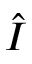Convert formula to latex. <formula><loc_0><loc_0><loc_500><loc_500>\hat { I }</formula> 